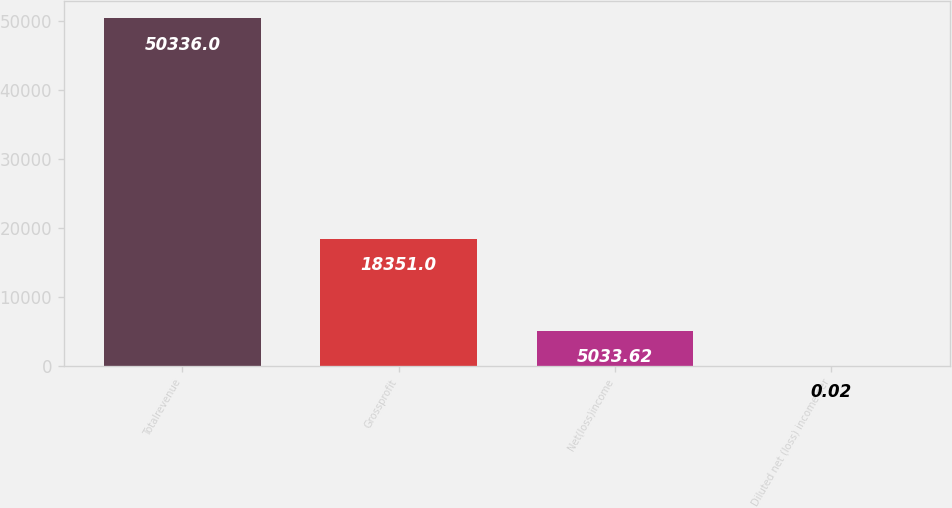<chart> <loc_0><loc_0><loc_500><loc_500><bar_chart><fcel>Totalrevenue<fcel>Grossprofit<fcel>Net(loss)income<fcel>Diluted net (loss) income per<nl><fcel>50336<fcel>18351<fcel>5033.62<fcel>0.02<nl></chart> 